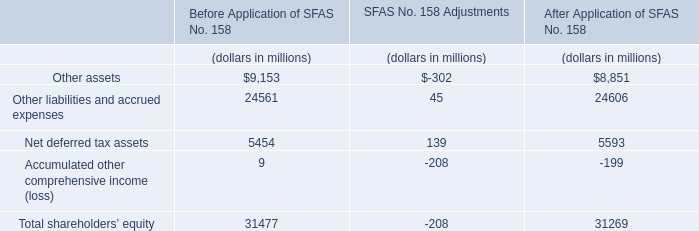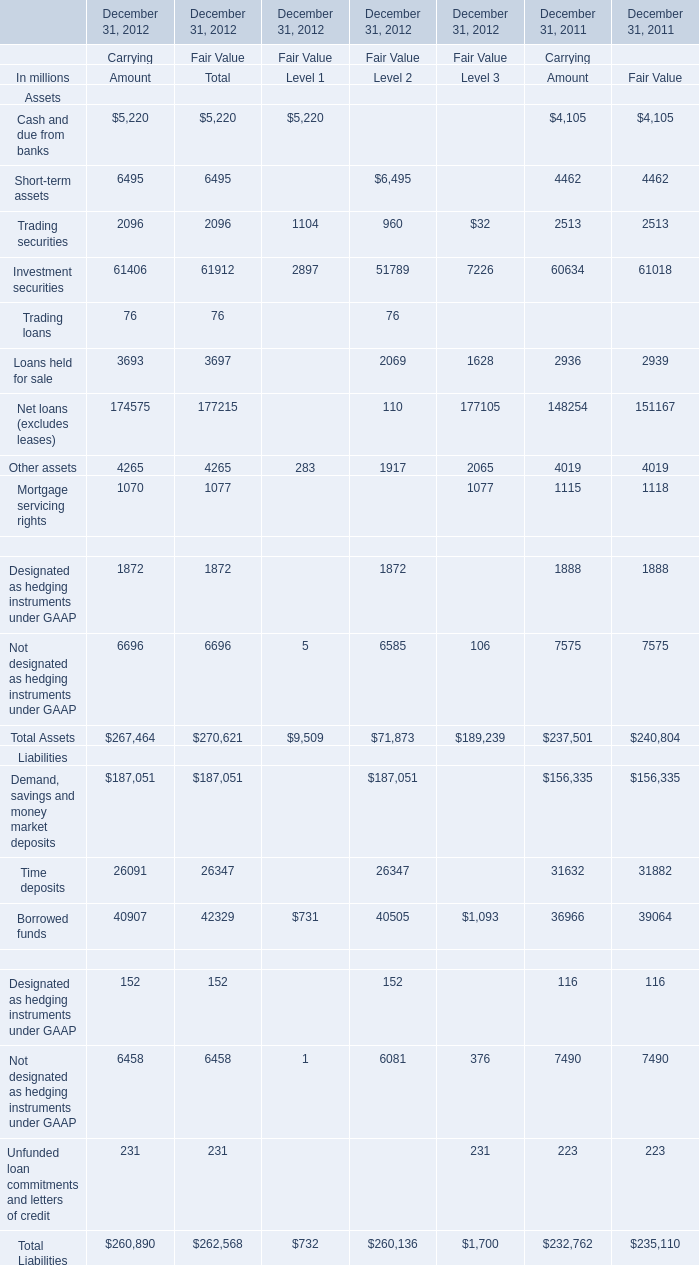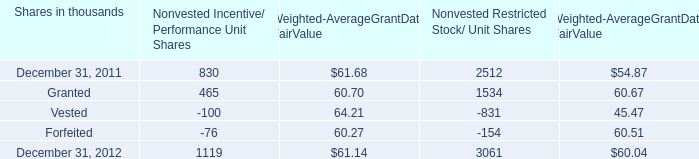What is the sum of Investment securities of December 31, 2012 Fair Value Level 3, December 31, 2011 of Nonvested Restricted Stock/ Unit Shares, and Loans held for sale of December 31, 2012 Carrying Amount ? 
Computations: ((7226.0 + 2512.0) + 3693.0)
Answer: 13431.0. 